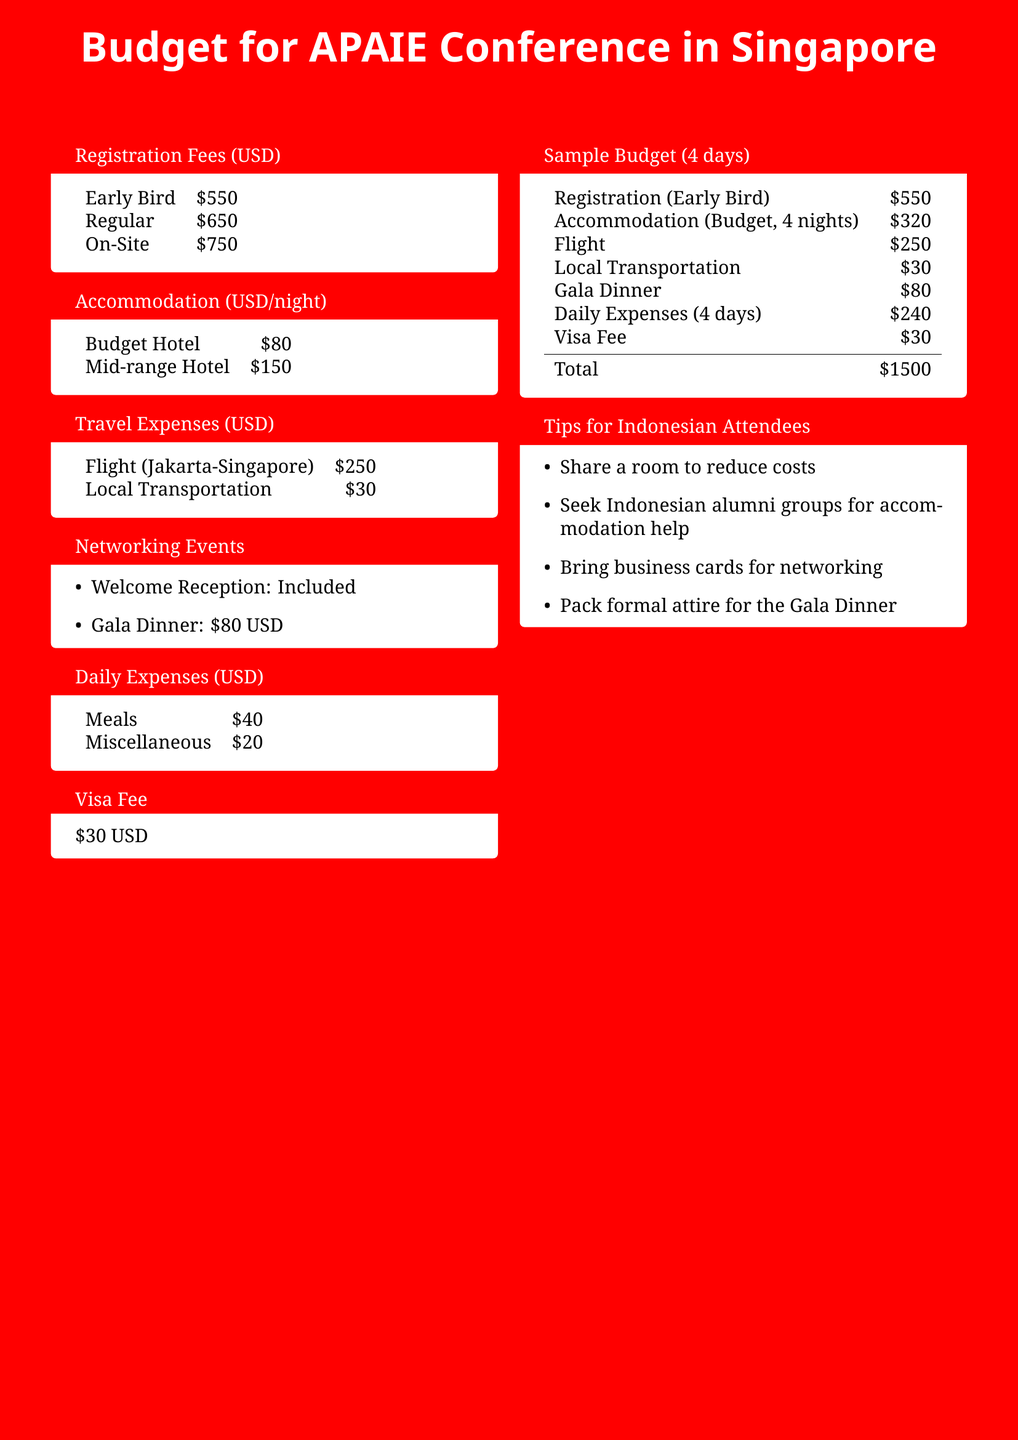What is the registration fee for the Early Bird rate? The registration fee for the Early Bird rate is listed under the Registration Fees section as $550.
Answer: $550 What is the accommodation cost per night for a Mid-range Hotel? The accommodation cost for a Mid-range Hotel is provided under the Accommodation section as $150 per night.
Answer: $150 How much does the Gala Dinner cost? The cost of the Gala Dinner is noted in the Networking Events section as $80.
Answer: $80 What is the total estimated budget for 4 days? The total estimated budget is calculated in the Sample Budget section as the sum of all listed costs, resulting in $1500.
Answer: $1500 How much is the Visa Fee? The Visa Fee is specified as $30 in its own section.
Answer: $30 What is the local transportation expense? The local transportation expense is included in the Travel Expenses section as $30.
Answer: $30 What is recommended to reduce accommodation costs? The Tips for Indonesian Attendees section suggests sharing a room to reduce costs.
Answer: Share a room How many nights of accommodation are included in the sample budget? The Sample Budget section indicates 4 nights of accommodation at a budget hotel.
Answer: 4 nights What type of attire should attendees pack for the Gala Dinner? The Tips section advises packing formal attire for the Gala Dinner.
Answer: Formal attire 